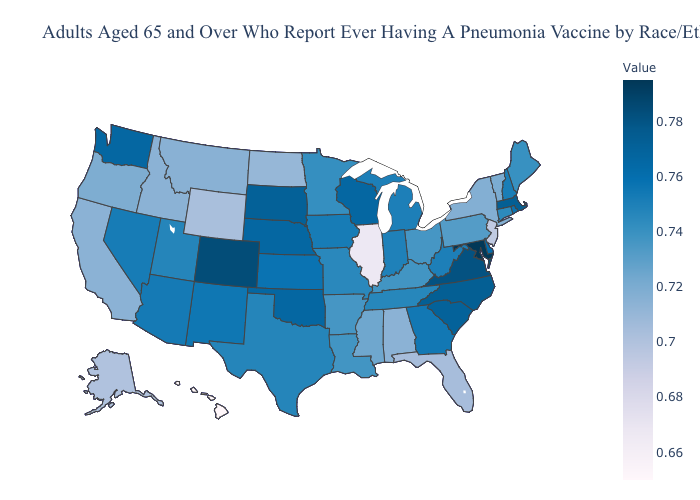Among the states that border West Virginia , which have the lowest value?
Short answer required. Pennsylvania. Does Wisconsin have a higher value than Maine?
Give a very brief answer. Yes. Does Maryland have the highest value in the USA?
Quick response, please. Yes. Does Idaho have the lowest value in the West?
Short answer required. No. 